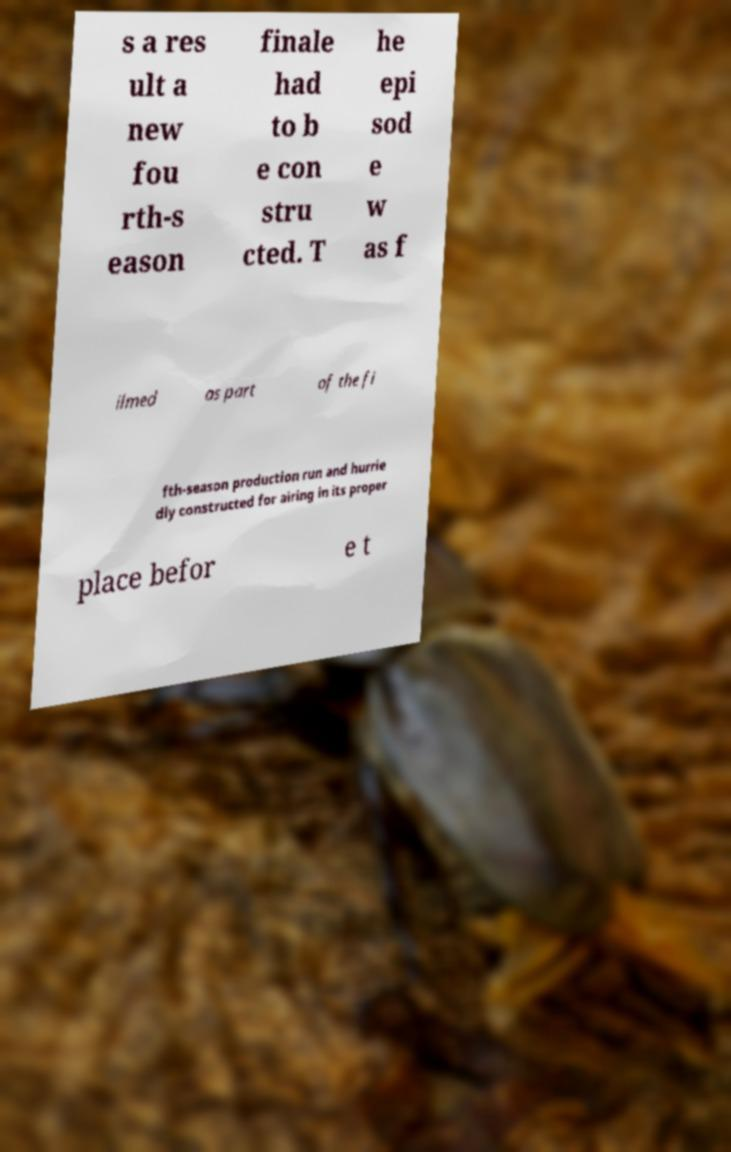Could you extract and type out the text from this image? s a res ult a new fou rth-s eason finale had to b e con stru cted. T he epi sod e w as f ilmed as part of the fi fth-season production run and hurrie dly constructed for airing in its proper place befor e t 